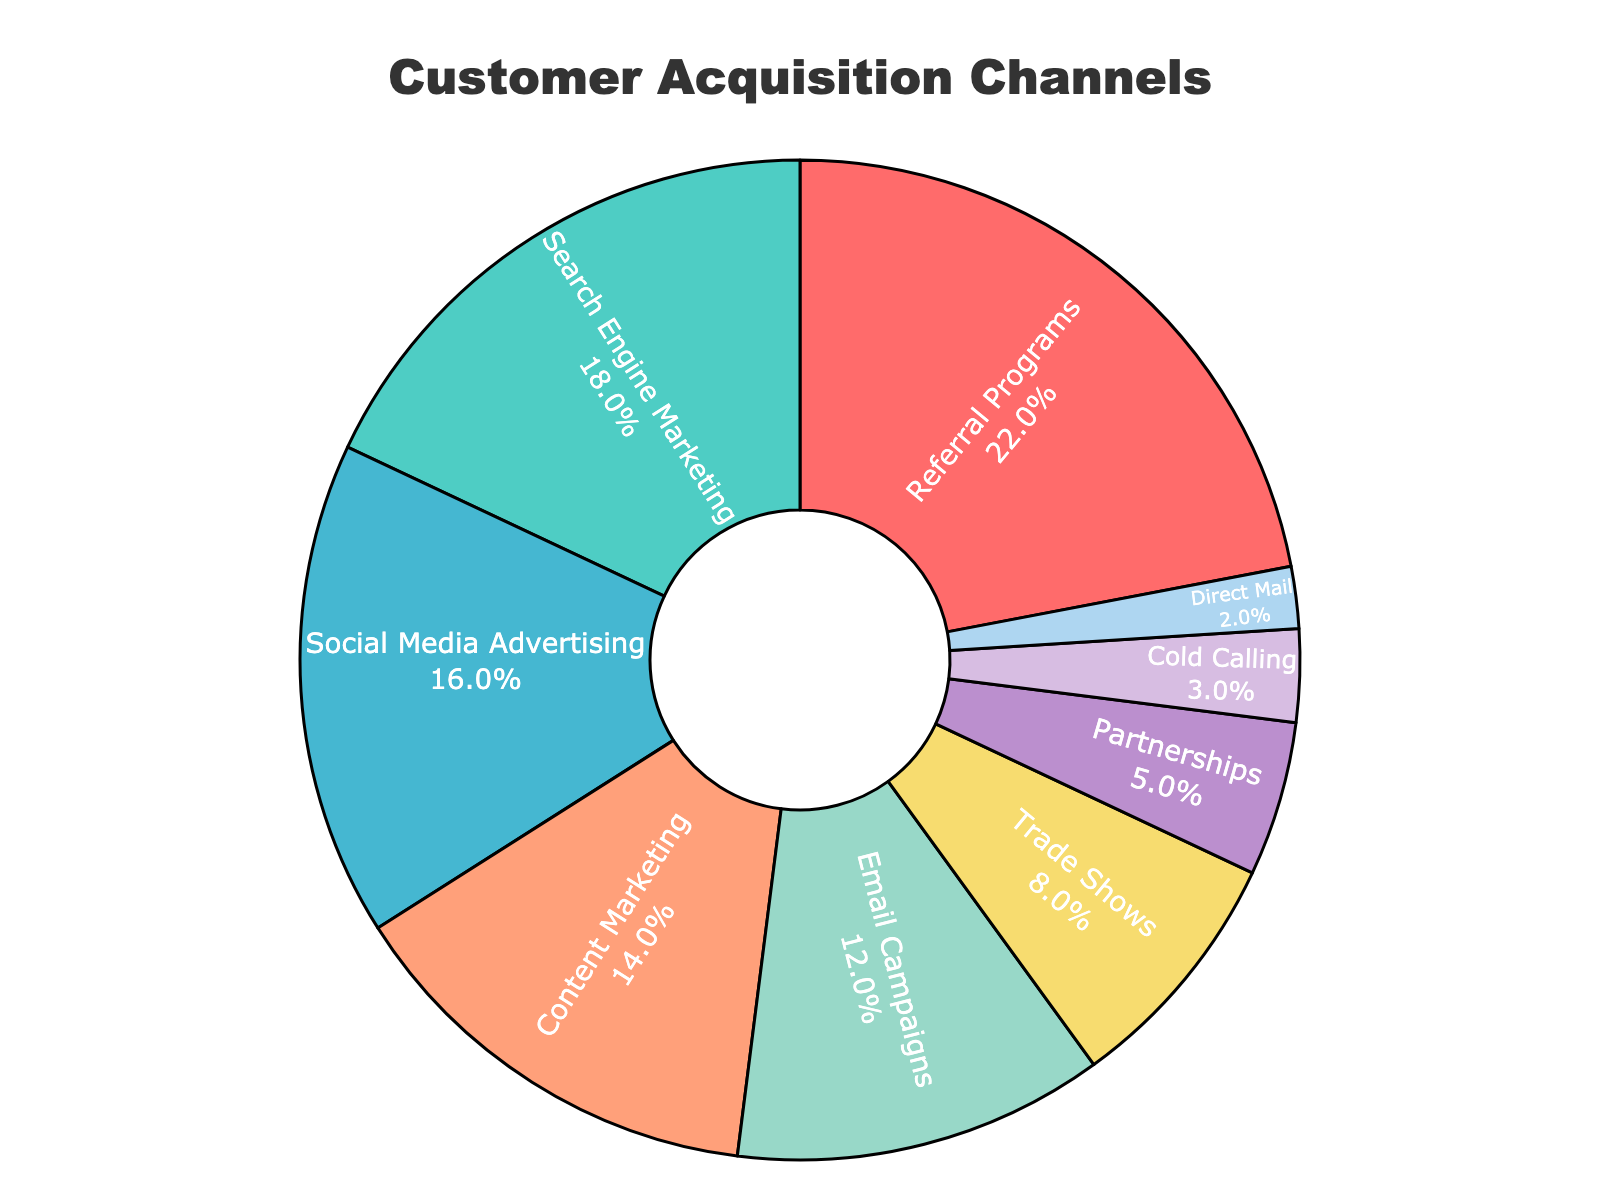What percentage of customers are acquired through referral programs? The percentage of customers acquired through referral programs is clearly labeled inside the relevant pie chart segment. The label reads 'Referral Programs 22%'.
Answer: 22% Which acquisition channel contributes the least to customer acquisition? By examining the smallest segment of the pie chart, we can identify that "Direct Mail" contributes the least to customer acquisition with a percentage labeled as 2%.
Answer: Direct Mail What is the combined percentage of customers acquired through social media advertising and content marketing? The percentage for Social Media Advertising is 16% and for Content Marketing is 14%. Adding these together, 16% + 14% = 30%.
Answer: 30% Are trade shows more effective than partnerships for customer acquisition, and by what percentage? Trade Shows contribute 8% while Partnerships contribute 5%. The difference is calculated by subtracting the smaller percentage from the larger one: 8% - 5% = 3%.
Answer: Yes, by 3% What channels account for more than 15% each of customer acquisition, and what are their combined percentages? Channels with more than 15% are Referral Programs (22%) and Search Engine Marketing (18%). The combined percentage is 22% + 18% = 40%.
Answer: Referral Programs and Search Engine Marketing, 40% What is the difference in percentage between the most and least effective customer acquisition channels? The most effective channel is Referral Programs at 22%, and the least effective is Direct Mail at 2%. The difference is calculated as 22% - 2% = 20%.
Answer: 20% Which acquisition channels are represented by blue-green and yellow colors, respectively? The color blue-green represents "Search Engine Marketing" with 18%, and yellow represents "Trade Shows" with 8%.
Answer: Search Engine Marketing and Trade Shows Is the sum of the percentages for Email Campaigns and Cold Calling greater than that for Content Marketing? The percentage for Email Campaigns is 12%, and for Cold Calling is 3%. Their sum is 12% + 3% = 15%. Content Marketing alone is 14%, so 15% is indeed greater than 14%.
Answer: Yes Which acquisition channels are visually adjacent to the "Social Media Advertising" segment on the pie chart? The segments adjacent to "Social Media Advertising" (orange) are "Search Engine Marketing" (aqua) and "Content Marketing" (light salmon).
Answer: Search Engine Marketing and Content Marketing 